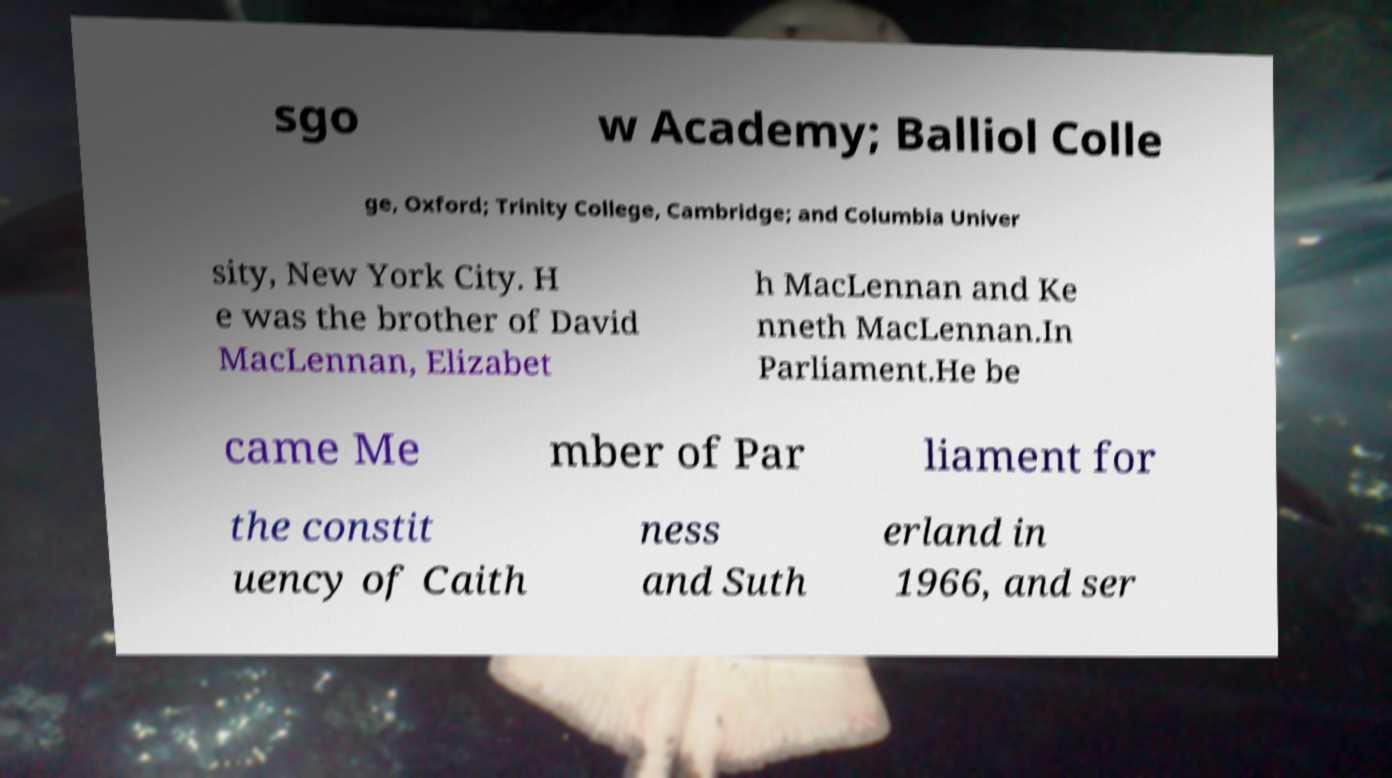Please read and relay the text visible in this image. What does it say? sgo w Academy; Balliol Colle ge, Oxford; Trinity College, Cambridge; and Columbia Univer sity, New York City. H e was the brother of David MacLennan, Elizabet h MacLennan and Ke nneth MacLennan.In Parliament.He be came Me mber of Par liament for the constit uency of Caith ness and Suth erland in 1966, and ser 